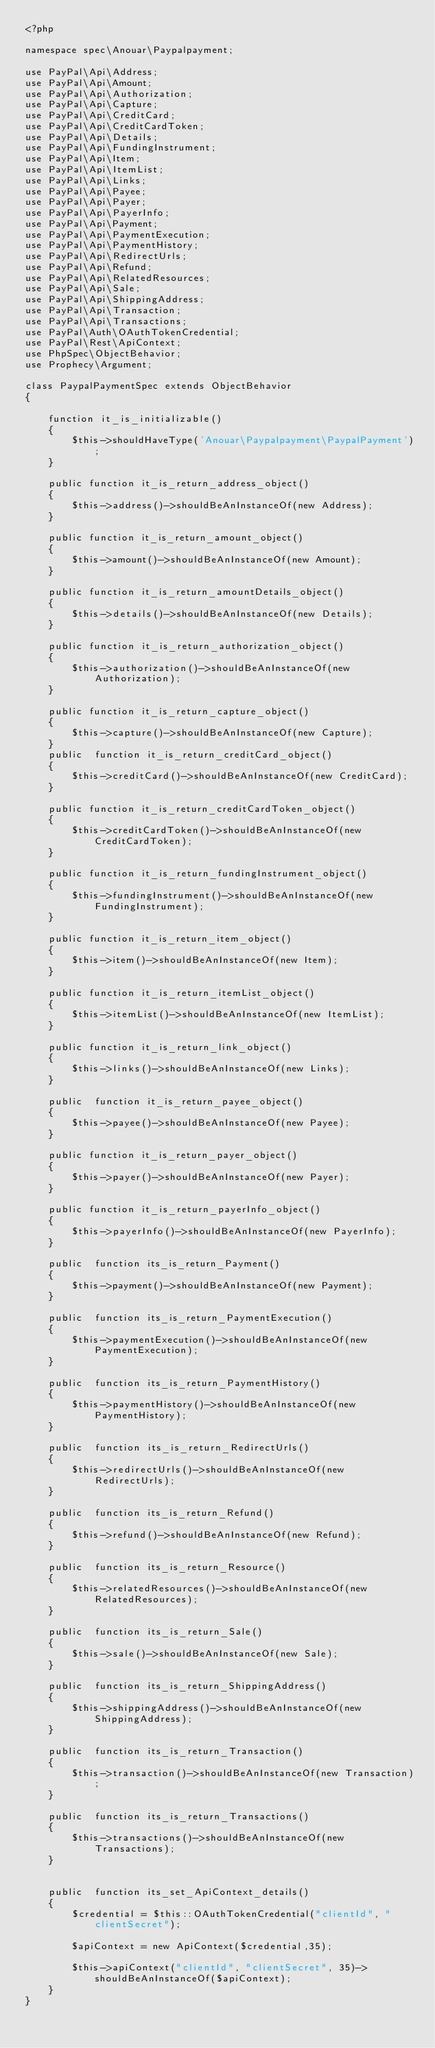Convert code to text. <code><loc_0><loc_0><loc_500><loc_500><_PHP_><?php

namespace spec\Anouar\Paypalpayment;

use PayPal\Api\Address;
use PayPal\Api\Amount;
use PayPal\Api\Authorization;
use PayPal\Api\Capture;
use PayPal\Api\CreditCard;
use PayPal\Api\CreditCardToken;
use PayPal\Api\Details;
use PayPal\Api\FundingInstrument;
use PayPal\Api\Item;
use PayPal\Api\ItemList;
use PayPal\Api\Links;
use PayPal\Api\Payee;
use PayPal\Api\Payer;
use PayPal\Api\PayerInfo;
use PayPal\Api\Payment;
use PayPal\Api\PaymentExecution;
use PayPal\Api\PaymentHistory;
use PayPal\Api\RedirectUrls;
use PayPal\Api\Refund;
use PayPal\Api\RelatedResources;
use PayPal\Api\Sale;
use PayPal\Api\ShippingAddress;
use PayPal\Api\Transaction;
use PayPal\Api\Transactions;
use PayPal\Auth\OAuthTokenCredential;
use PayPal\Rest\ApiContext;
use PhpSpec\ObjectBehavior;
use Prophecy\Argument;

class PaypalPaymentSpec extends ObjectBehavior
{

    function it_is_initializable()
    {
        $this->shouldHaveType('Anouar\Paypalpayment\PaypalPayment');
    }

    public function it_is_return_address_object()
    {
        $this->address()->shouldBeAnInstanceOf(new Address);
    }

    public function it_is_return_amount_object()
    {
        $this->amount()->shouldBeAnInstanceOf(new Amount);
    }

    public function it_is_return_amountDetails_object()
    {
        $this->details()->shouldBeAnInstanceOf(new Details);
    }

    public function it_is_return_authorization_object()
    {
        $this->authorization()->shouldBeAnInstanceOf(new Authorization);
    }

    public function it_is_return_capture_object()
    {
        $this->capture()->shouldBeAnInstanceOf(new Capture);
    }
    public  function it_is_return_creditCard_object()
    {
        $this->creditCard()->shouldBeAnInstanceOf(new CreditCard);
    }

    public function it_is_return_creditCardToken_object()
    {
        $this->creditCardToken()->shouldBeAnInstanceOf(new CreditCardToken);
    }

    public function it_is_return_fundingInstrument_object()
    {
        $this->fundingInstrument()->shouldBeAnInstanceOf(new FundingInstrument);
    }

    public function it_is_return_item_object()
    {
        $this->item()->shouldBeAnInstanceOf(new Item);
    }

    public function it_is_return_itemList_object()
    {
        $this->itemList()->shouldBeAnInstanceOf(new ItemList);
    }

    public function it_is_return_link_object()
    {
        $this->links()->shouldBeAnInstanceOf(new Links);
    }

    public  function it_is_return_payee_object()
    {
        $this->payee()->shouldBeAnInstanceOf(new Payee);
    }

    public function it_is_return_payer_object()
    {
        $this->payer()->shouldBeAnInstanceOf(new Payer);
    }

    public function it_is_return_payerInfo_object()
    {
        $this->payerInfo()->shouldBeAnInstanceOf(new PayerInfo);
    }

    public  function its_is_return_Payment()
    {
        $this->payment()->shouldBeAnInstanceOf(new Payment);
    }

    public  function its_is_return_PaymentExecution()
    {
        $this->paymentExecution()->shouldBeAnInstanceOf(new PaymentExecution);
    }

    public  function its_is_return_PaymentHistory()
    {
        $this->paymentHistory()->shouldBeAnInstanceOf(new PaymentHistory);
    }

    public  function its_is_return_RedirectUrls()
    {
        $this->redirectUrls()->shouldBeAnInstanceOf(new RedirectUrls);
    }

    public  function its_is_return_Refund()
    {
        $this->refund()->shouldBeAnInstanceOf(new Refund);
    }

    public  function its_is_return_Resource()
    {
        $this->relatedResources()->shouldBeAnInstanceOf(new RelatedResources);
    }

    public  function its_is_return_Sale()
    {
        $this->sale()->shouldBeAnInstanceOf(new Sale);
    }

    public  function its_is_return_ShippingAddress()
    {
        $this->shippingAddress()->shouldBeAnInstanceOf(new ShippingAddress);
    }

    public  function its_is_return_Transaction()
    {
        $this->transaction()->shouldBeAnInstanceOf(new Transaction);
    }

    public  function its_is_return_Transactions()
    {
        $this->transactions()->shouldBeAnInstanceOf(new Transactions);
    }


    public  function its_set_ApiContext_details()
    {
        $credential = $this::OAuthTokenCredential("clientId", "clientSecret");

        $apiContext = new ApiContext($credential,35);

        $this->apiContext("clientId", "clientSecret", 35)->shouldBeAnInstanceOf($apiContext);
    }
}
</code> 